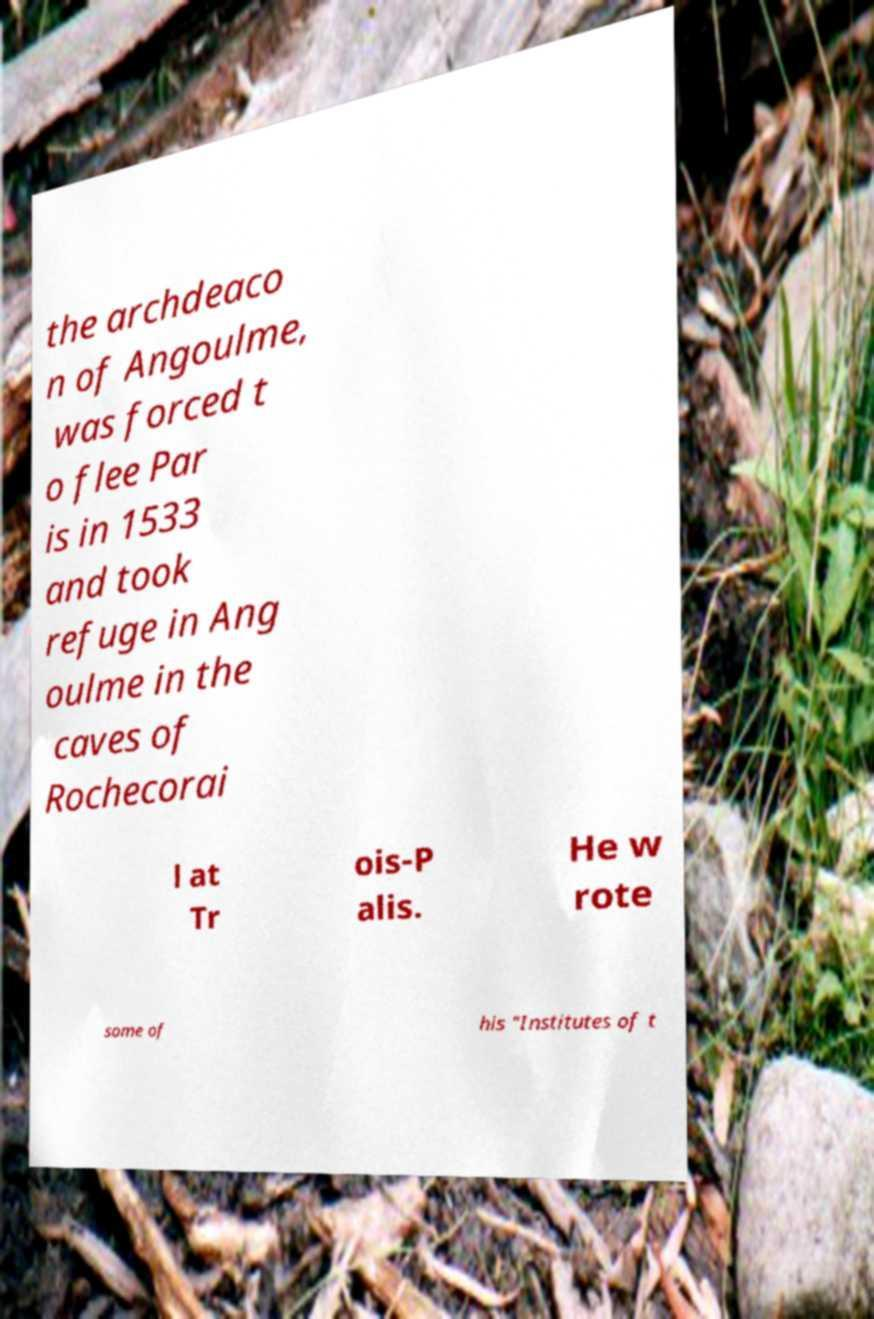Could you extract and type out the text from this image? the archdeaco n of Angoulme, was forced t o flee Par is in 1533 and took refuge in Ang oulme in the caves of Rochecorai l at Tr ois-P alis. He w rote some of his "Institutes of t 